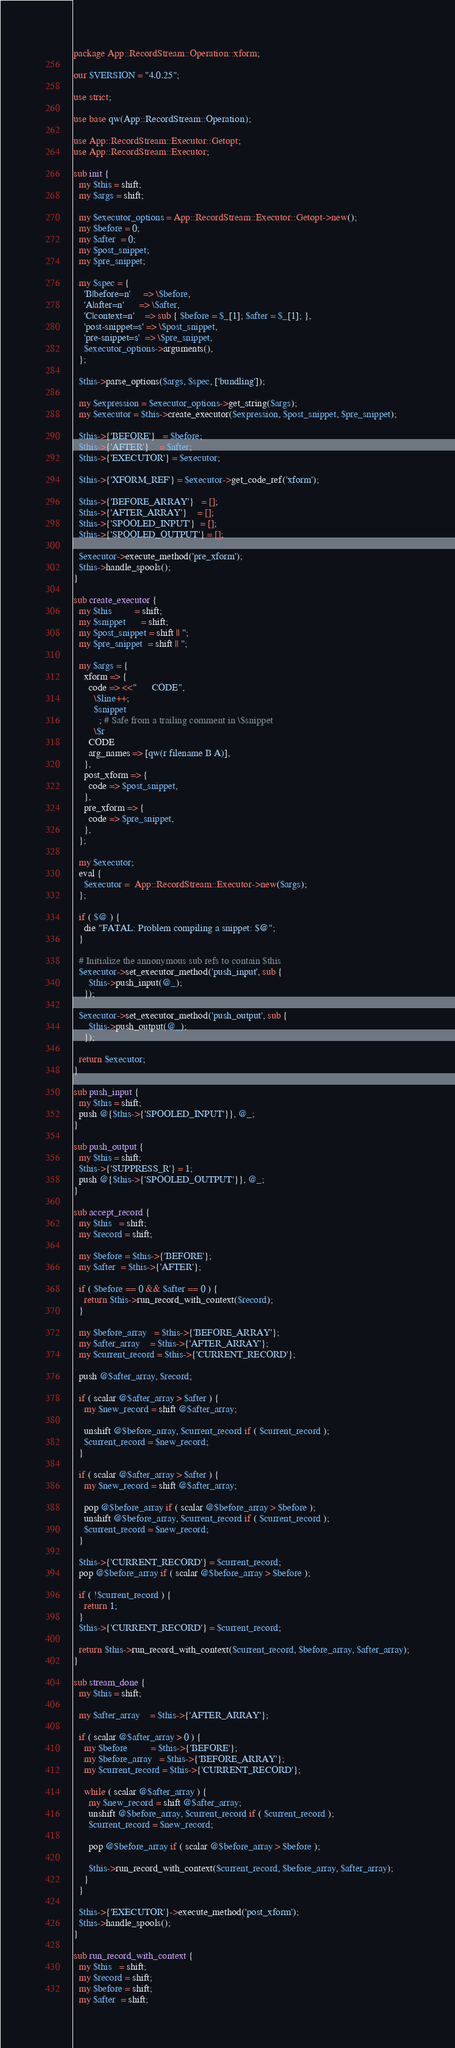Convert code to text. <code><loc_0><loc_0><loc_500><loc_500><_Perl_>package App::RecordStream::Operation::xform;

our $VERSION = "4.0.25";

use strict;

use base qw(App::RecordStream::Operation);

use App::RecordStream::Executor::Getopt;
use App::RecordStream::Executor;

sub init {
  my $this = shift;
  my $args = shift;

  my $executor_options = App::RecordStream::Executor::Getopt->new();
  my $before = 0;
  my $after  = 0;
  my $post_snippet;
  my $pre_snippet;

  my $spec = {
    'B|before=n'     => \$before,
    'A|after=n'      => \$after,
    'C|context=n'    => sub { $before = $_[1]; $after = $_[1]; },
    'post-snippet=s' => \$post_snippet,
    'pre-snippet=s'  => \$pre_snippet,
    $executor_options->arguments(),
  };

  $this->parse_options($args, $spec, ['bundling']);

  my $expression = $executor_options->get_string($args);
  my $executor = $this->create_executor($expression, $post_snippet, $pre_snippet);

  $this->{'BEFORE'}   = $before;
  $this->{'AFTER'}    = $after;
  $this->{'EXECUTOR'} = $executor;

  $this->{'XFORM_REF'} = $executor->get_code_ref('xform');

  $this->{'BEFORE_ARRAY'}   = [];
  $this->{'AFTER_ARRAY'}    = [];
  $this->{'SPOOLED_INPUT'}  = [];
  $this->{'SPOOLED_OUTPUT'} = [];

  $executor->execute_method('pre_xform');
  $this->handle_spools();
}

sub create_executor {
  my $this         = shift;
  my $snippet      = shift;
  my $post_snippet = shift || '';
  my $pre_snippet  = shift || '';

  my $args = {
    xform => {
      code => <<"      CODE",
        \$line++;
        $snippet
          ; # Safe from a trailing comment in \$snippet
        \$r
      CODE
      arg_names => [qw(r filename B A)],
    },
    post_xform => {
      code => $post_snippet,
    },
    pre_xform => {
      code => $pre_snippet,
    },
  };

  my $executor;
  eval {
    $executor =  App::RecordStream::Executor->new($args);
  };

  if ( $@ ) {
    die "FATAL: Problem compiling a snippet: $@";
  }

  # Initialize the annonymous sub refs to contain $this
  $executor->set_executor_method('push_input', sub {
      $this->push_input(@_);
    });

  $executor->set_executor_method('push_output', sub {
      $this->push_output(@_);
    });

  return $executor;
}

sub push_input {
  my $this = shift;
  push @{$this->{'SPOOLED_INPUT'}}, @_;
}

sub push_output {
  my $this = shift;
  $this->{'SUPPRESS_R'} = 1;
  push @{$this->{'SPOOLED_OUTPUT'}}, @_;
}

sub accept_record {
  my $this   = shift;
  my $record = shift;

  my $before = $this->{'BEFORE'};
  my $after  = $this->{'AFTER'};

  if ( $before == 0 && $after == 0 ) {
    return $this->run_record_with_context($record);
  }

  my $before_array   = $this->{'BEFORE_ARRAY'};
  my $after_array    = $this->{'AFTER_ARRAY'};
  my $current_record = $this->{'CURRENT_RECORD'};

  push @$after_array, $record;

  if ( scalar @$after_array > $after ) {
    my $new_record = shift @$after_array;

    unshift @$before_array, $current_record if ( $current_record );
    $current_record = $new_record;
  }

  if ( scalar @$after_array > $after ) {
    my $new_record = shift @$after_array;

    pop @$before_array if ( scalar @$before_array > $before );
    unshift @$before_array, $current_record if ( $current_record );
    $current_record = $new_record;
  }

  $this->{'CURRENT_RECORD'} = $current_record;
  pop @$before_array if ( scalar @$before_array > $before );

  if ( !$current_record ) {
    return 1;
  }
  $this->{'CURRENT_RECORD'} = $current_record;

  return $this->run_record_with_context($current_record, $before_array, $after_array);
}

sub stream_done {
  my $this = shift;

  my $after_array    = $this->{'AFTER_ARRAY'};

  if ( scalar @$after_array > 0 ) {
    my $before         = $this->{'BEFORE'};
    my $before_array   = $this->{'BEFORE_ARRAY'};
    my $current_record = $this->{'CURRENT_RECORD'};

    while ( scalar @$after_array ) {
      my $new_record = shift @$after_array;
      unshift @$before_array, $current_record if ( $current_record );
      $current_record = $new_record;

      pop @$before_array if ( scalar @$before_array > $before );

      $this->run_record_with_context($current_record, $before_array, $after_array);
    }
  }

  $this->{'EXECUTOR'}->execute_method('post_xform');
  $this->handle_spools();
}

sub run_record_with_context {
  my $this   = shift;
  my $record = shift;
  my $before = shift;
  my $after  = shift;
</code> 